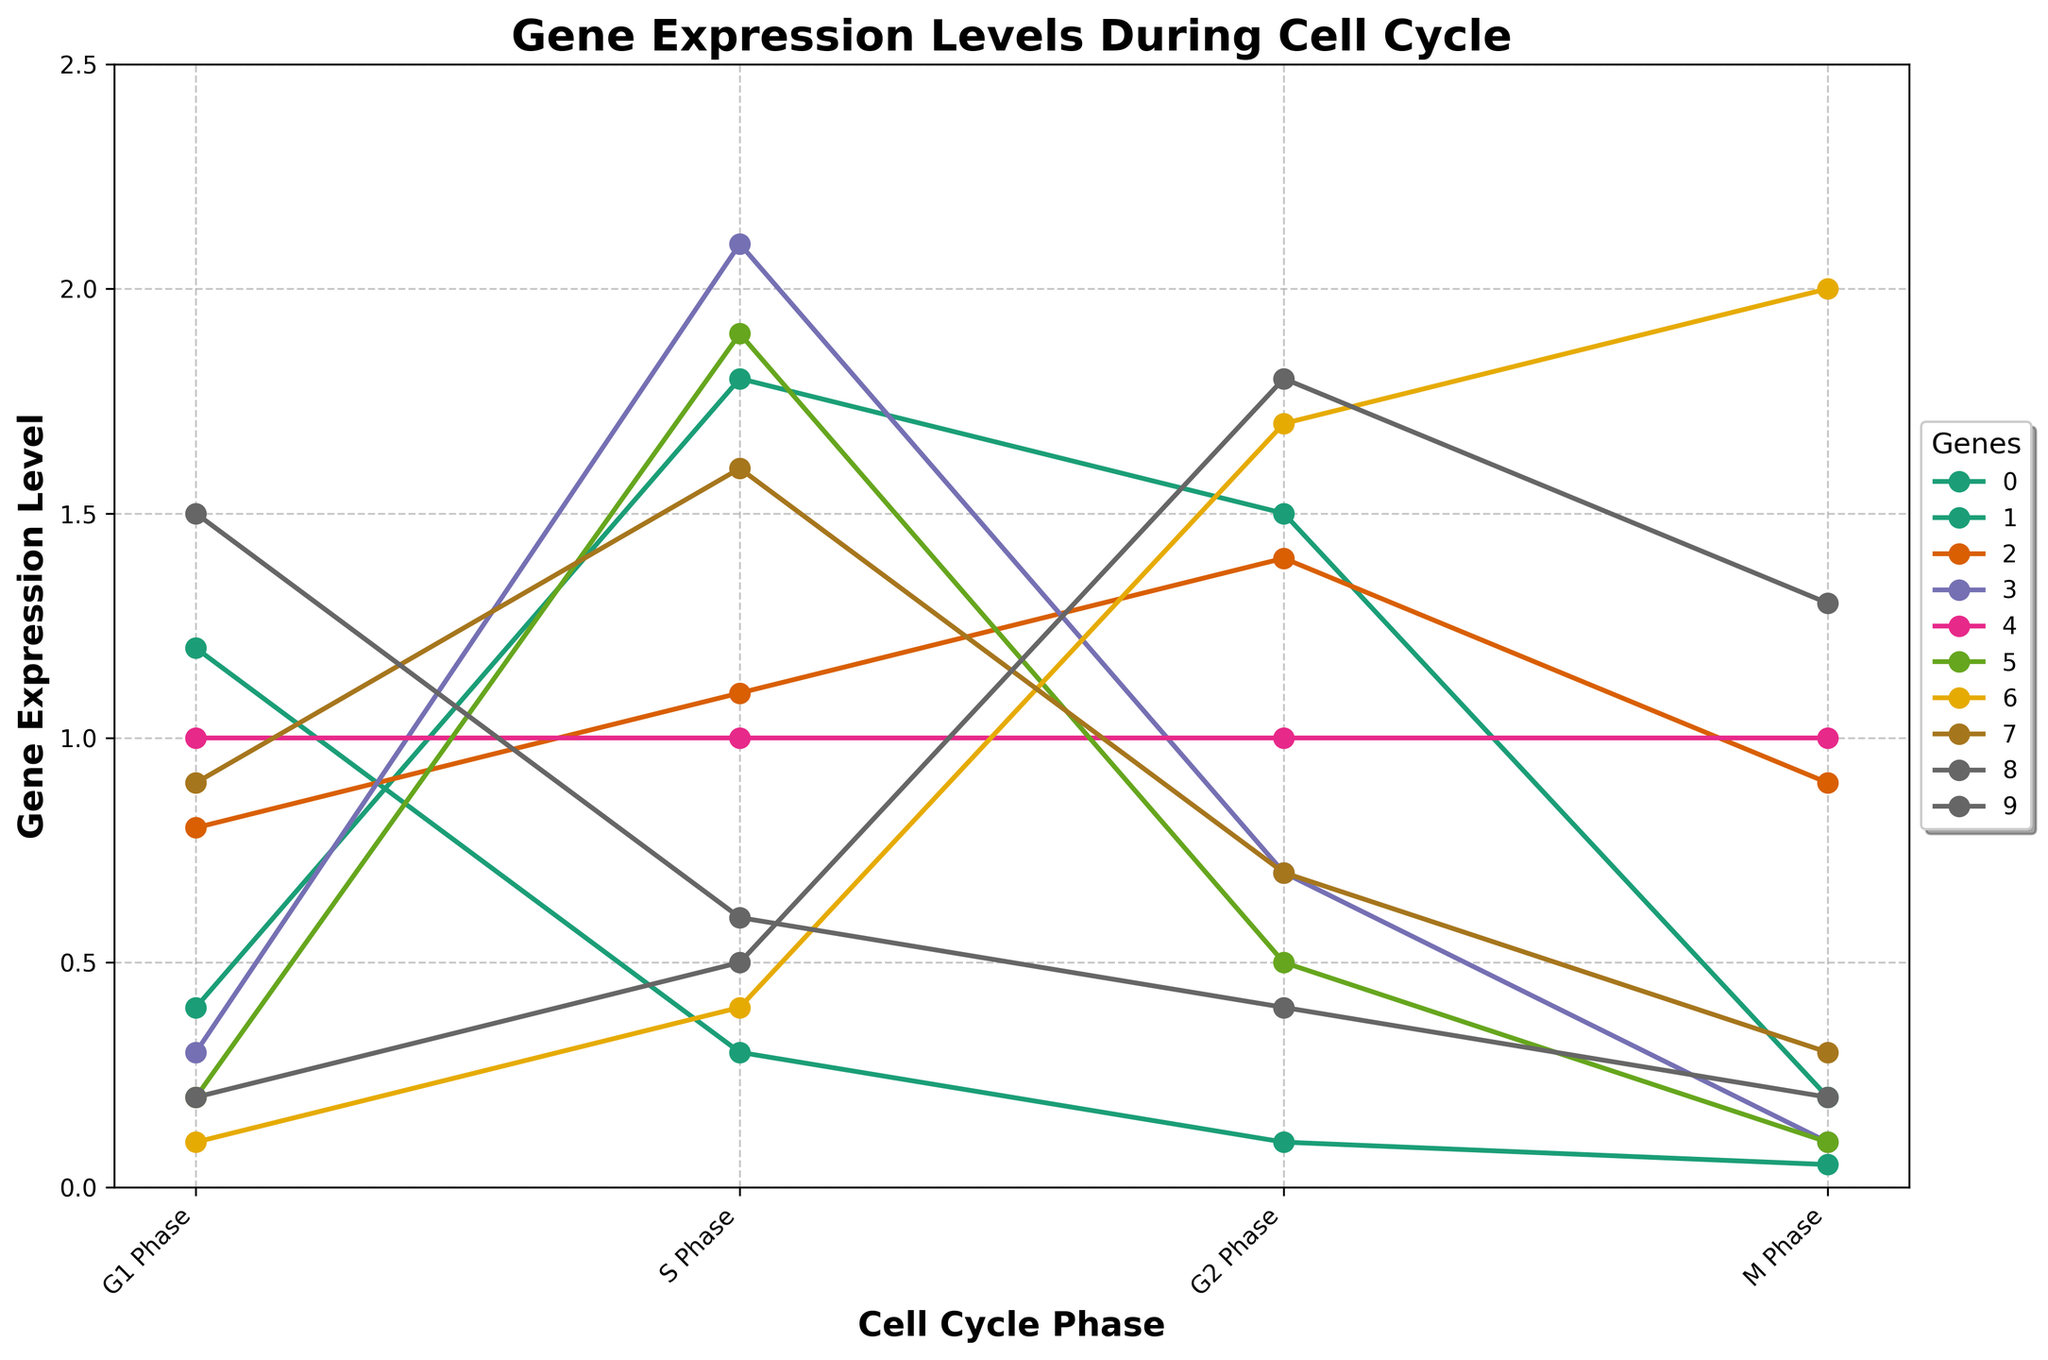What gene has the highest expression level during the S Phase? To find the gene with the highest expression level in the S Phase, look at the 'S Phase' column and identify the maximum value. The highest value is 2.1, which corresponds to gene PCNA.
Answer: PCNA Which phase does the Cyclin D1 gene have its lowest expression level? Look at Cyclin D1's values across all phases: (G1: 1.2, S: 0.3, G2: 0.1, M: 0.05). The minimum value is 0.05, which occurs in the M Phase.
Answer: M Phase What's the difference in gene expression levels of CDK2 between the S Phase and the M Phase? For CDK2, subtract the M Phase value from the S Phase value: 1.8 (S Phase) - 0.2 (M Phase) = 1.6.
Answer: 1.6 What is the average expression level of the p53 gene across all phases? Calculate the average of p53's expression levels: (0.8 (G1) + 1.1 (S) + 1.4 (G2) + 0.9 (M))/4 = 1.05.
Answer: 1.05 Which gene shows the most variation in expression levels across different phases? To find the gene with the most variation, look at the range (max - min) for each gene:
- Cyclin D1: 1.2 - 0.05 = 1.15
- CDK2: 1.8 - 0.2 = 1.6
- p53: 1.4 - 0.8 = 0.6 
- PCNA: 2.1 - 0.1 = 2.0 
- GAPDH: 1.0 - 1.0 = 0 
- MCM2: 1.9 - 0.1 = 1.8
- CCNB1: 2.0 - 0.1 = 1.9 
- E2F1: 1.6 - 0.3 = 1.3 
- RB1: 1.5 - 0.2 = 1.3 
- CDC25C: 1.8 - 0.2 = 1.6
PCNA has the highest range (2.0).
Answer: PCNA How does the expression level of MCM2 during the G2 Phase compare to that of the RB1 in the same phase? Look at the G2 Phase values for both genes: MCM2 (0.5) and RB1 (0.4). Compare the two values; MCM2's expression level is higher than RB1's.
Answer: MCM2 > RB1 Which genes have constant expression levels throughout all phases? Check for genes that have the same values across all phases. Only GAPDH has constant values (1.0 in all phases).
Answer: GAPDH What is the sum of Cyclin D1 expression levels in G1 and M phases? Add the expression levels of Cyclin D1 in G1 and M phases: 1.2 (G1) + 0.05 (M) = 1.25.
Answer: 1.25 During which phase do we see the highest expression of CCNB1? Look at CCNB1's values across all phases: (G1: 0.1, S: 0.4, G2: 1.7, M: 2.0). The highest value is in the M Phase with 2.0.
Answer: M Phase What is the median expression level of E2F1 across different phases? Arrange E2F1's values in numerical order: 0.3, 0.7, 0.9, 1.6. The median is the average of the two middle values (0.7 and 0.9). (0.7 + 0.9)/2 = 0.8.
Answer: 0.8 